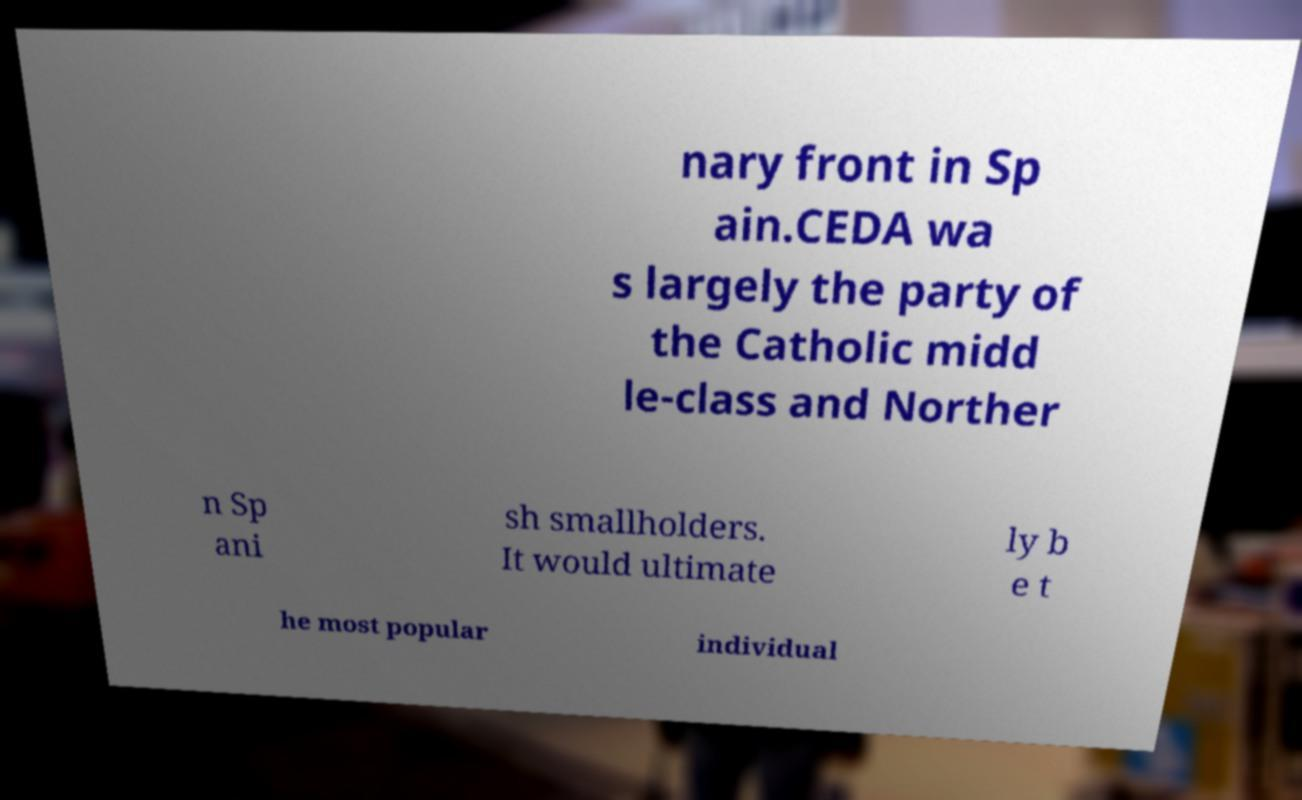What messages or text are displayed in this image? I need them in a readable, typed format. nary front in Sp ain.CEDA wa s largely the party of the Catholic midd le-class and Norther n Sp ani sh smallholders. It would ultimate ly b e t he most popular individual 